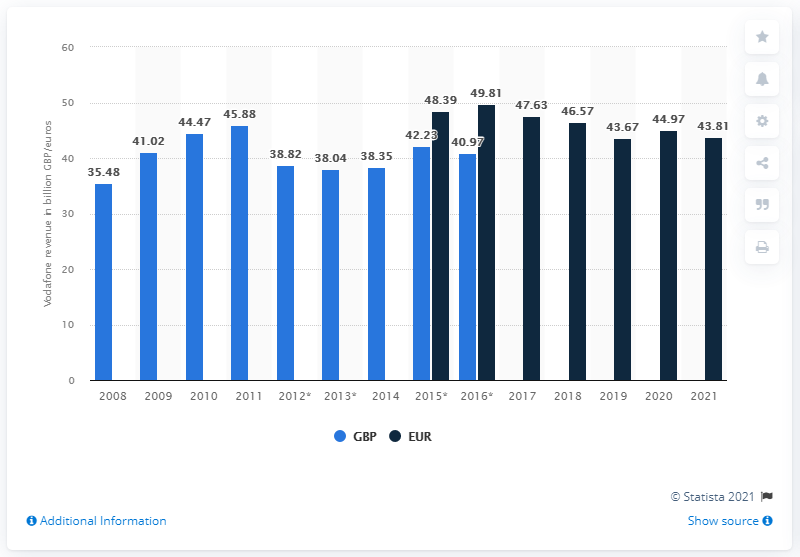Outline some significant characteristics in this image. Vodafone's total revenue in 2021 was 43.81. Vodafone's revenue decreased by 43.81% in 2021 compared to the previous year. 